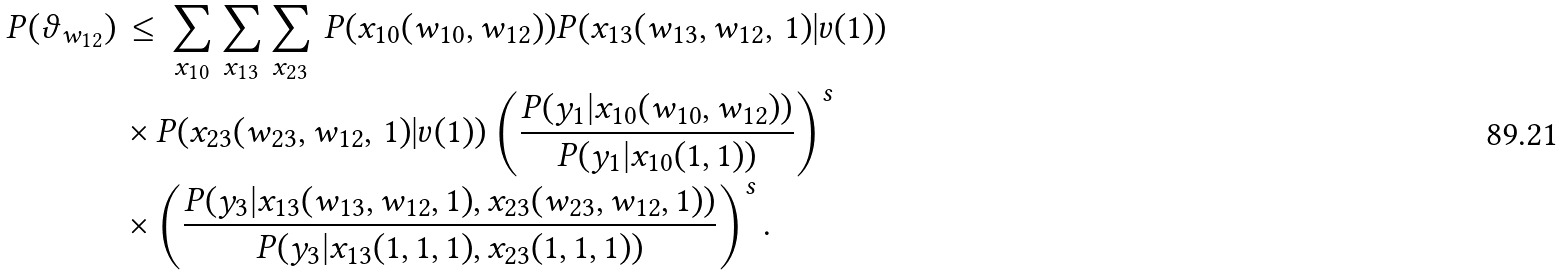<formula> <loc_0><loc_0><loc_500><loc_500>P ( \vartheta _ { w _ { 1 2 } } ) \, & \leq \, \sum _ { x _ { 1 0 } } \sum _ { x _ { 1 3 } } \sum _ { x _ { 2 3 } } \, P ( x _ { 1 0 } ( w _ { 1 0 } , w _ { 1 2 } ) ) P ( x _ { 1 3 } ( w _ { 1 3 } , w _ { 1 2 } , \, 1 ) | v ( 1 ) ) \\ & \times P ( x _ { 2 3 } ( w _ { 2 3 } , w _ { 1 2 } , \, 1 ) | v ( 1 ) ) \left ( \frac { P ( y _ { 1 } | x _ { 1 0 } ( w _ { 1 0 } , w _ { 1 2 } ) ) } { P ( y _ { 1 } | x _ { 1 0 } ( 1 , 1 ) ) } \right ) ^ { s } \\ & \times \left ( \frac { P ( y _ { 3 } | x _ { 1 3 } ( w _ { 1 3 } , w _ { 1 2 } , 1 ) , x _ { 2 3 } ( w _ { 2 3 } , w _ { 1 2 } , 1 ) ) } { P ( y _ { 3 } | x _ { 1 3 } ( 1 , 1 , 1 ) , x _ { 2 3 } ( 1 , 1 , 1 ) ) } \right ) ^ { s } .</formula> 